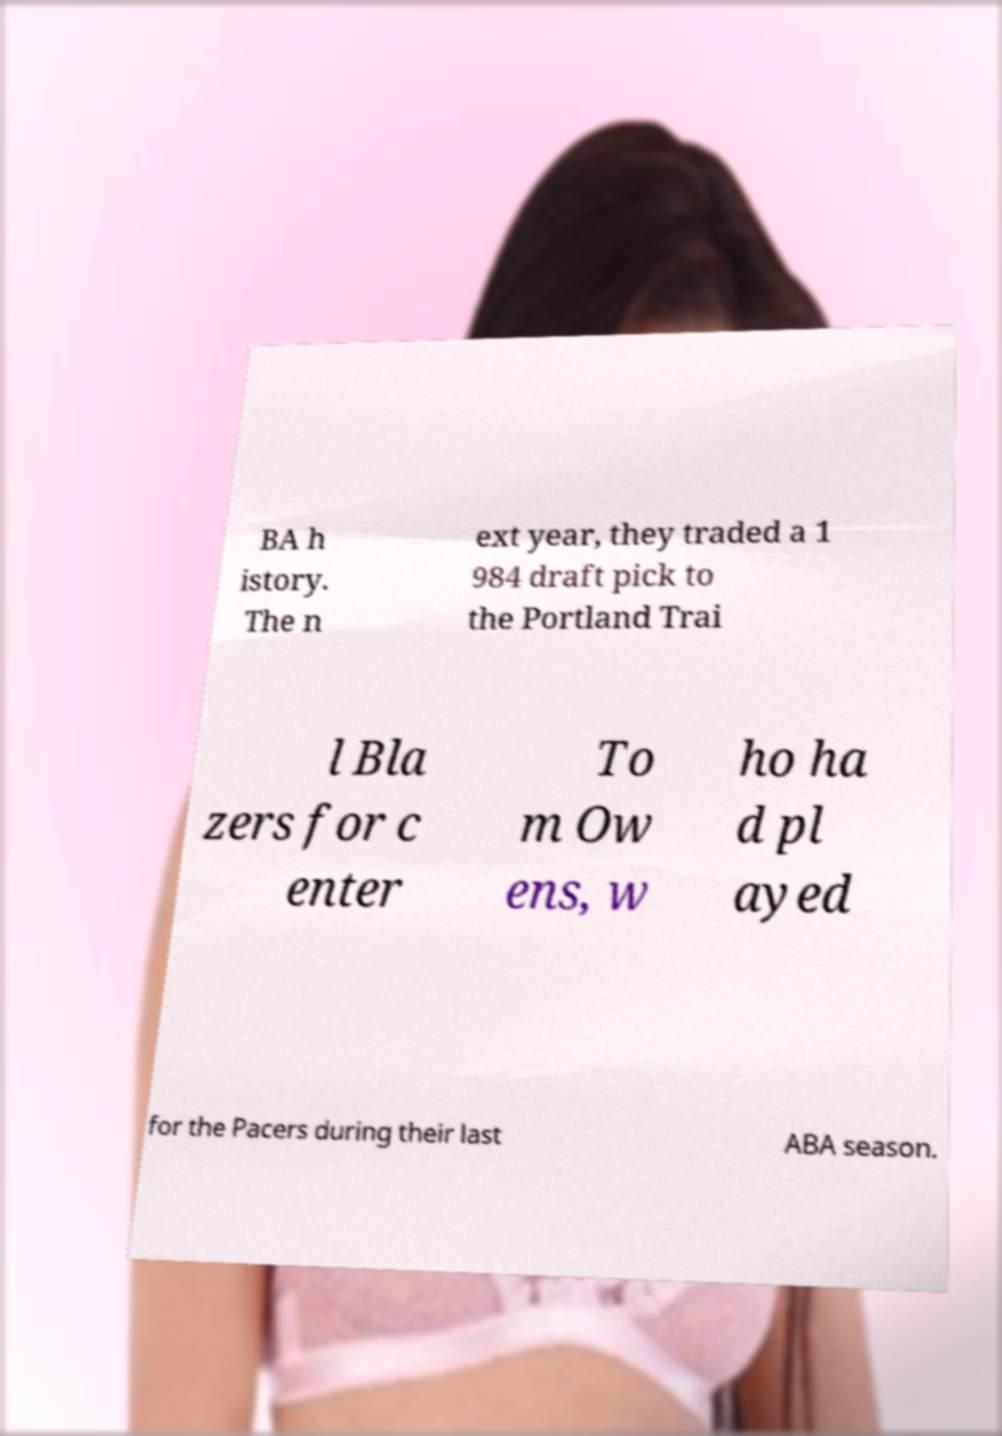Could you assist in decoding the text presented in this image and type it out clearly? BA h istory. The n ext year, they traded a 1 984 draft pick to the Portland Trai l Bla zers for c enter To m Ow ens, w ho ha d pl ayed for the Pacers during their last ABA season. 